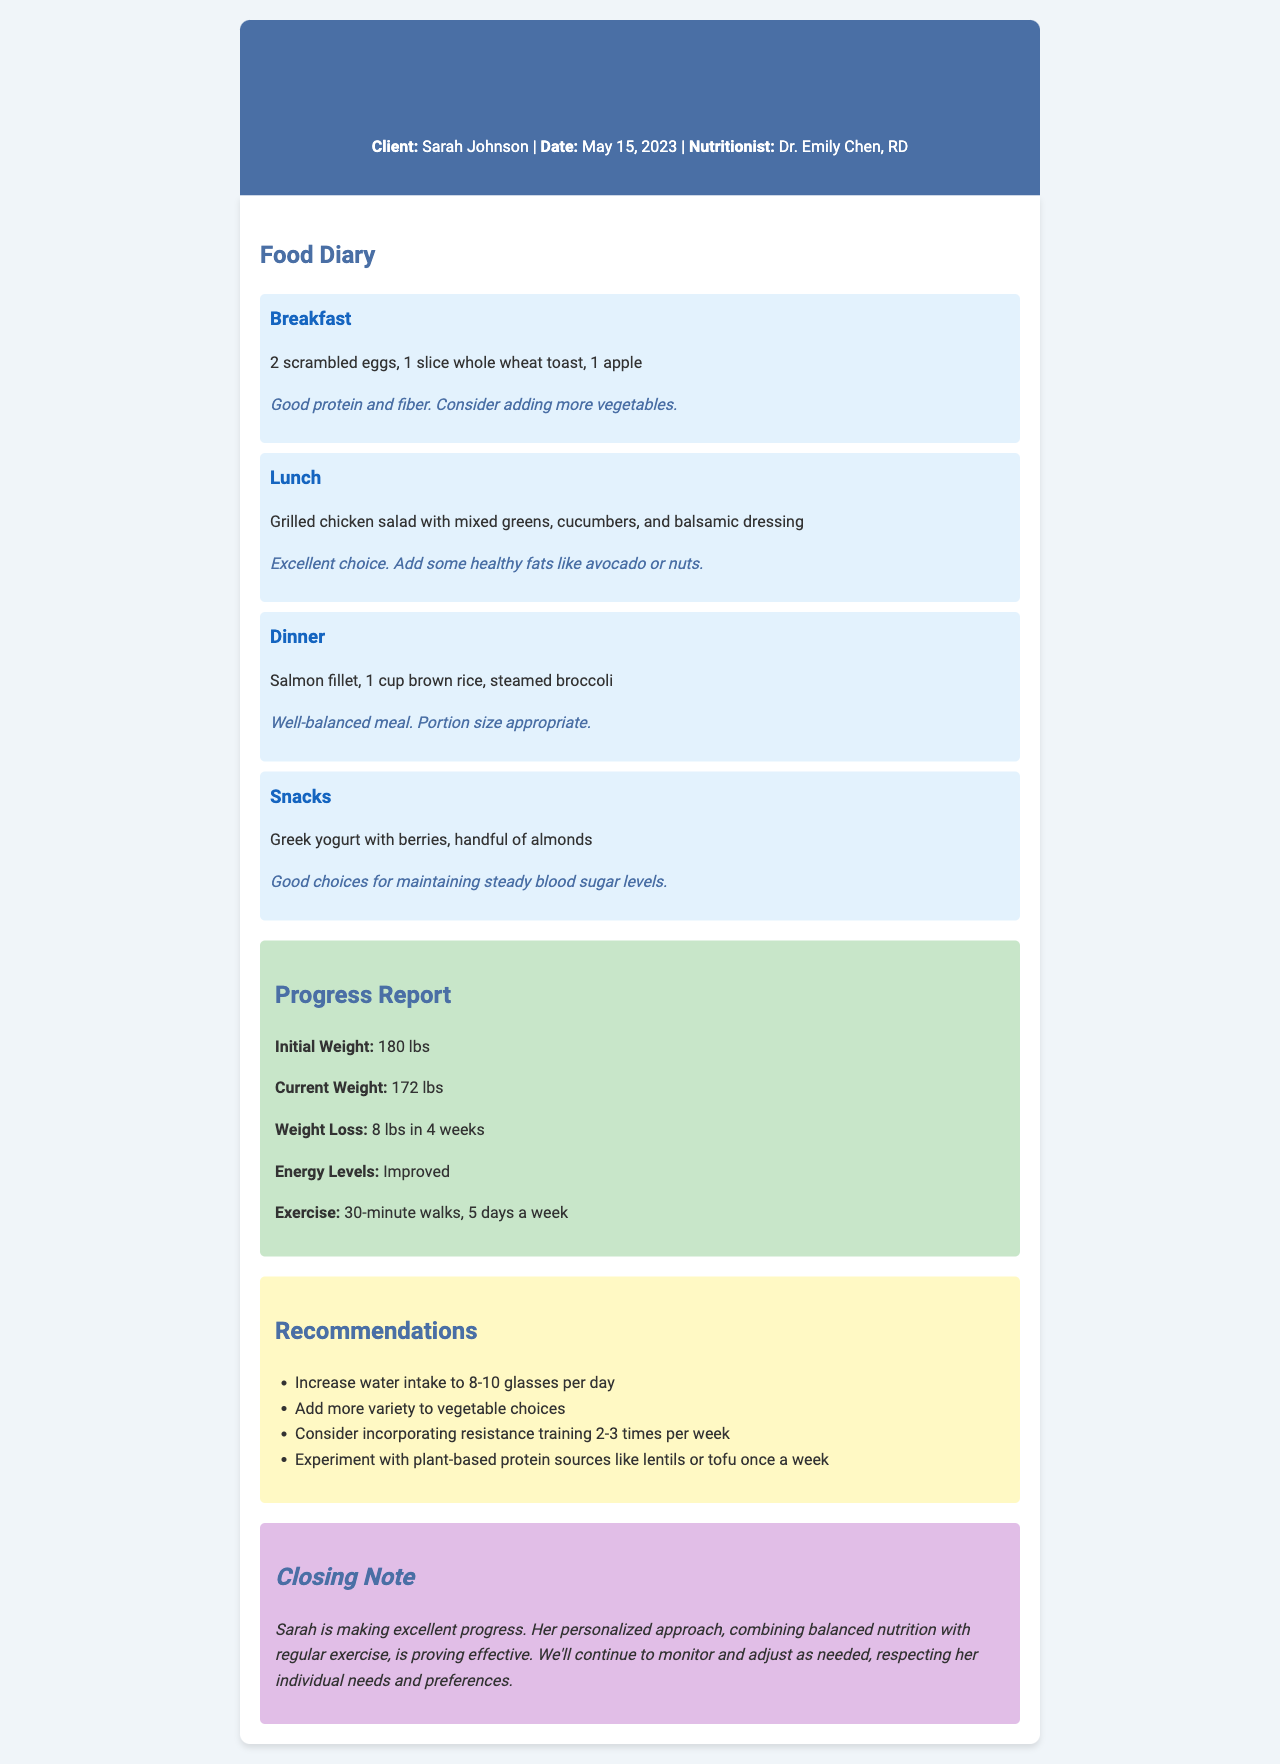What is the client's name? The client's name is mentioned at the top of the document.
Answer: Sarah Johnson What is the initial weight of the client? The initial weight is provided in the Progress Report section of the document.
Answer: 180 lbs What is the current weight of the client? The current weight is stated directly in the Progress Report section.
Answer: 172 lbs How many pounds has the client lost? The weight loss is detailed in the Progress Report, calculating the difference from initial to current weight.
Answer: 8 lbs What improvements are noted in the client's energy levels? The Energy Levels section indicates the change over time based on the client’s feedback.
Answer: Improved What type of exercise is the client doing? The document specifies the type of exercise the client is engaged in.
Answer: 30-minute walks How often does the client exercise per week? The frequency of the client's exercise is mentioned in the Progress Report.
Answer: 5 days a week What is recommended for the client's water intake? The recommendations section provides specific hydration advice.
Answer: 8-10 glasses per day Which protein sources are suggested to experiment with? The recommendations mention specific plant-based protein sources to incorporate.
Answer: Lentils or tofu 